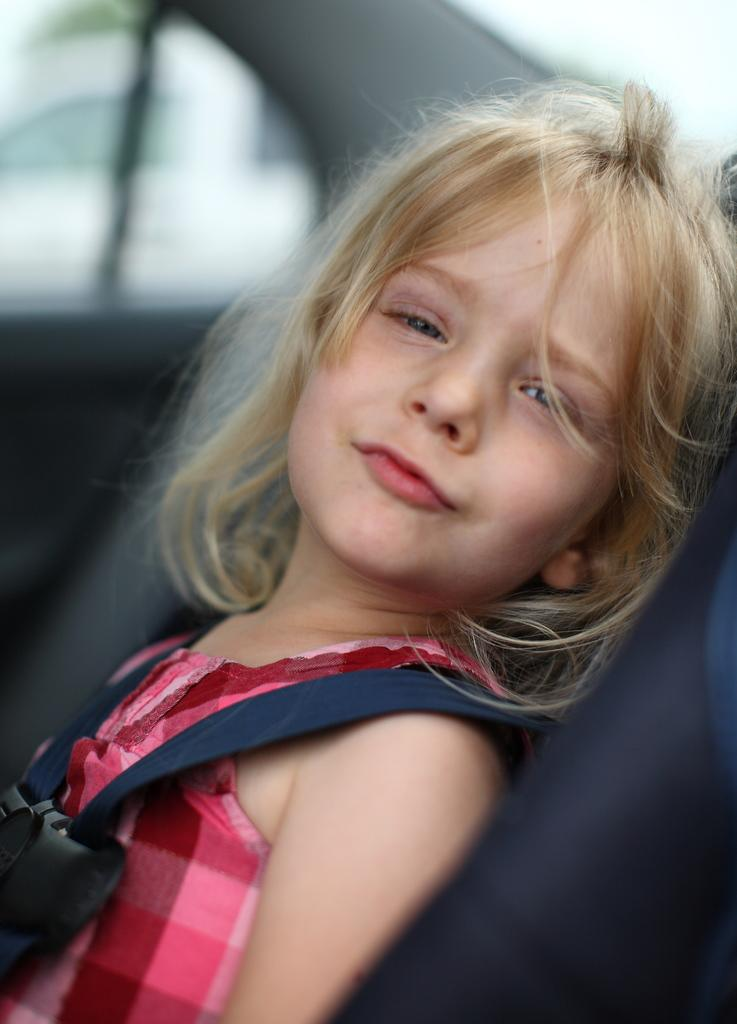Who is the main subject in the image? There is a girl in the image. What is the girl's facial expression? The girl has a smiling face. Where is the girl located in the image? The girl is sitting in a vehicle that looks like a car. What can be seen in the background of the image? There is a white object in the background of the image. How would you describe the background of the image? The background of the image is blurred. What type of hat is the girl wearing in the image? The girl is not wearing a hat in the image. What nation is the girl representing in the image? The image does not provide any information about the girl representing a specific nation. 